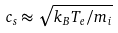<formula> <loc_0><loc_0><loc_500><loc_500>c _ { s } \approx \sqrt { k _ { B } T _ { e } / m _ { i } }</formula> 